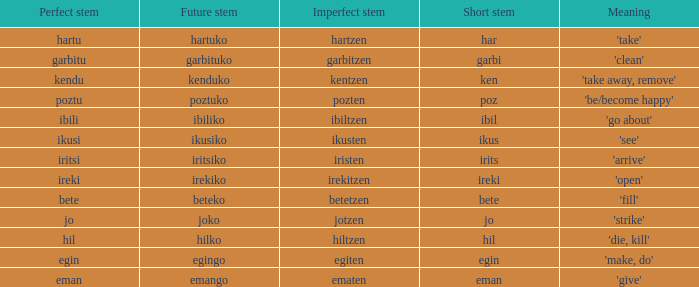What is the short stem for garbitzen? Garbi. 